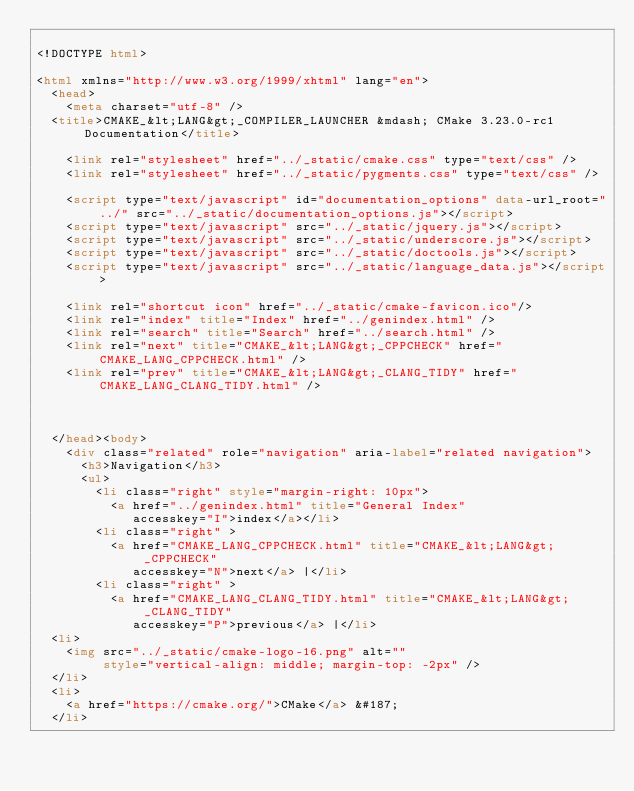<code> <loc_0><loc_0><loc_500><loc_500><_HTML_>
<!DOCTYPE html>

<html xmlns="http://www.w3.org/1999/xhtml" lang="en">
  <head>
    <meta charset="utf-8" />
  <title>CMAKE_&lt;LANG&gt;_COMPILER_LAUNCHER &mdash; CMake 3.23.0-rc1 Documentation</title>

    <link rel="stylesheet" href="../_static/cmake.css" type="text/css" />
    <link rel="stylesheet" href="../_static/pygments.css" type="text/css" />
    
    <script type="text/javascript" id="documentation_options" data-url_root="../" src="../_static/documentation_options.js"></script>
    <script type="text/javascript" src="../_static/jquery.js"></script>
    <script type="text/javascript" src="../_static/underscore.js"></script>
    <script type="text/javascript" src="../_static/doctools.js"></script>
    <script type="text/javascript" src="../_static/language_data.js"></script>
    
    <link rel="shortcut icon" href="../_static/cmake-favicon.ico"/>
    <link rel="index" title="Index" href="../genindex.html" />
    <link rel="search" title="Search" href="../search.html" />
    <link rel="next" title="CMAKE_&lt;LANG&gt;_CPPCHECK" href="CMAKE_LANG_CPPCHECK.html" />
    <link rel="prev" title="CMAKE_&lt;LANG&gt;_CLANG_TIDY" href="CMAKE_LANG_CLANG_TIDY.html" />
  
 

  </head><body>
    <div class="related" role="navigation" aria-label="related navigation">
      <h3>Navigation</h3>
      <ul>
        <li class="right" style="margin-right: 10px">
          <a href="../genindex.html" title="General Index"
             accesskey="I">index</a></li>
        <li class="right" >
          <a href="CMAKE_LANG_CPPCHECK.html" title="CMAKE_&lt;LANG&gt;_CPPCHECK"
             accesskey="N">next</a> |</li>
        <li class="right" >
          <a href="CMAKE_LANG_CLANG_TIDY.html" title="CMAKE_&lt;LANG&gt;_CLANG_TIDY"
             accesskey="P">previous</a> |</li>
  <li>
    <img src="../_static/cmake-logo-16.png" alt=""
         style="vertical-align: middle; margin-top: -2px" />
  </li>
  <li>
    <a href="https://cmake.org/">CMake</a> &#187;
  </li></code> 